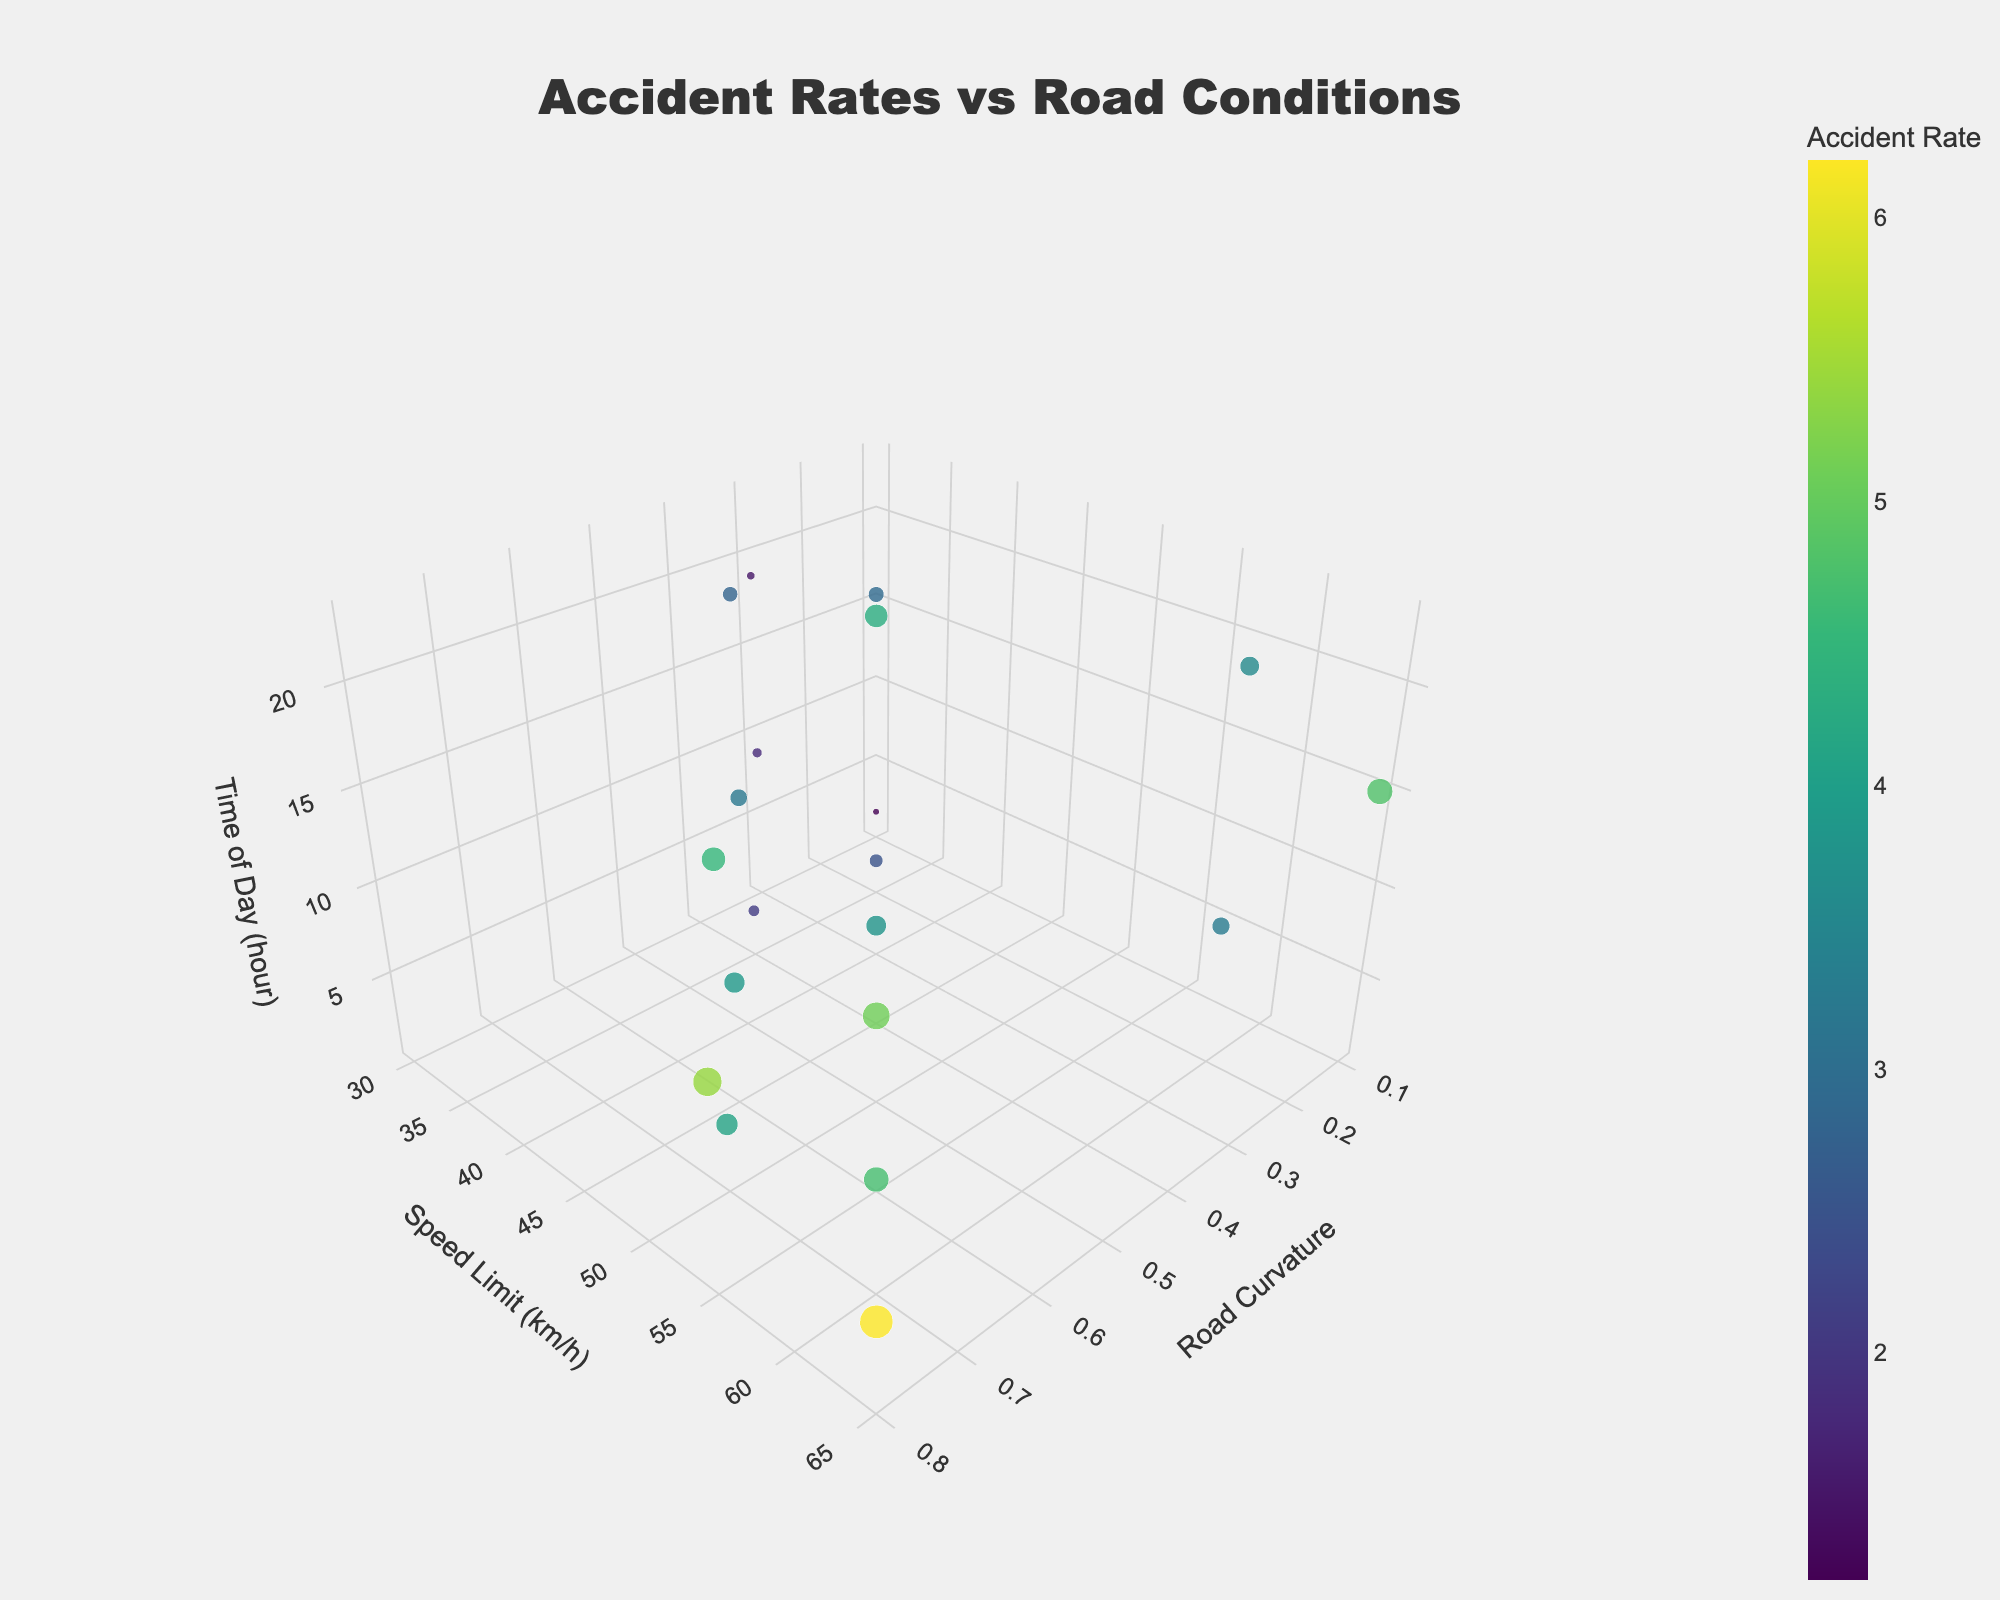What is the title of the figure? The title of the figure is written at the top and is usually in larger, bold text. In this figure, the title is "Accident Rates vs Road Conditions."
Answer: "Accident Rates vs Road Conditions" What are the three axes labeled in the plot? The axis labels are textual descriptions found on each of the three axes. In this figure, they are: "Road Curvature" (x-axis), "Speed Limit (km/h)" (y-axis), and "Time of Day (hour)" (z-axis).
Answer: "Road Curvature," "Speed Limit (km/h)," "Time of Day (hour)" How many data points are represented in this 3D plot? Count the number of individual markers or points in the 3D scatter plot. This plot has 20 data points.
Answer: 20 Which data point has the highest accident rate? By examining the color intensity and size of the markers, the point with the highest accident rate is identified. The point with Road Curvature: 0.8, Speed Limit: 65, Time of Day: 5, has an Accident Rate of 6.2.
Answer: Road Curvature: 0.8, Speed Limit: 65, Time of Day: 5, Accident Rate: 6.2 What is the accident rate when the Road Curvature is 0.2, and Time of Day is 18? Locate the specific marker with Road Curvature: 0.2 and Time of Day: 18. The Speed Limit here is 35, and the Accident Rate is 2.9.
Answer: 2.9 Compare the accident rates for the lowest and highest speed limits on curves with Road Curvature 0.8. Locate the markers with Road Curvature 0.8. The Speed Limits are 55 and 65. The respective Accident Rates are 5.4 and 6.2.
Answer: 5.4 for Speed Limit 55, 6.2 for Speed Limit 65 Identify the point with the lowest accident rate and give its conditions. Identify the smallest and least intense colored marker. The lowest accident rate is at Road Curvature: 0.1, Speed Limit: 30, Time of Day: 2, with an Accident Rate of 1.2.
Answer: Road Curvature: 0.1, Speed Limit: 30, Time of Day: 2, Accident Rate: 1.2 What trend do you observe in accident rates as road curvature increases? Observe the markers along the road curvature axis: As curvature increases, the markers generally become larger and more intensely colored, indicating an increase in accident rates.
Answer: Accident rates tend to increase as road curvature increases Do higher speed limits correlate with higher accident rates in this plot? Compare accident rates across different speed limits and identify if markers tend to get larger and darker as speed limits increase. Generally, accident rates increase with higher speed limits.
Answer: Yes, higher speed limits generally correlate with higher accident rates What is the accident rate for a road curvature of 0.4 and speed limit of 45? Locate the marker with these conditions: Road Curvature 0.4, Speed Limit 45. The Accident Rate is 4.3.
Answer: 4.3 